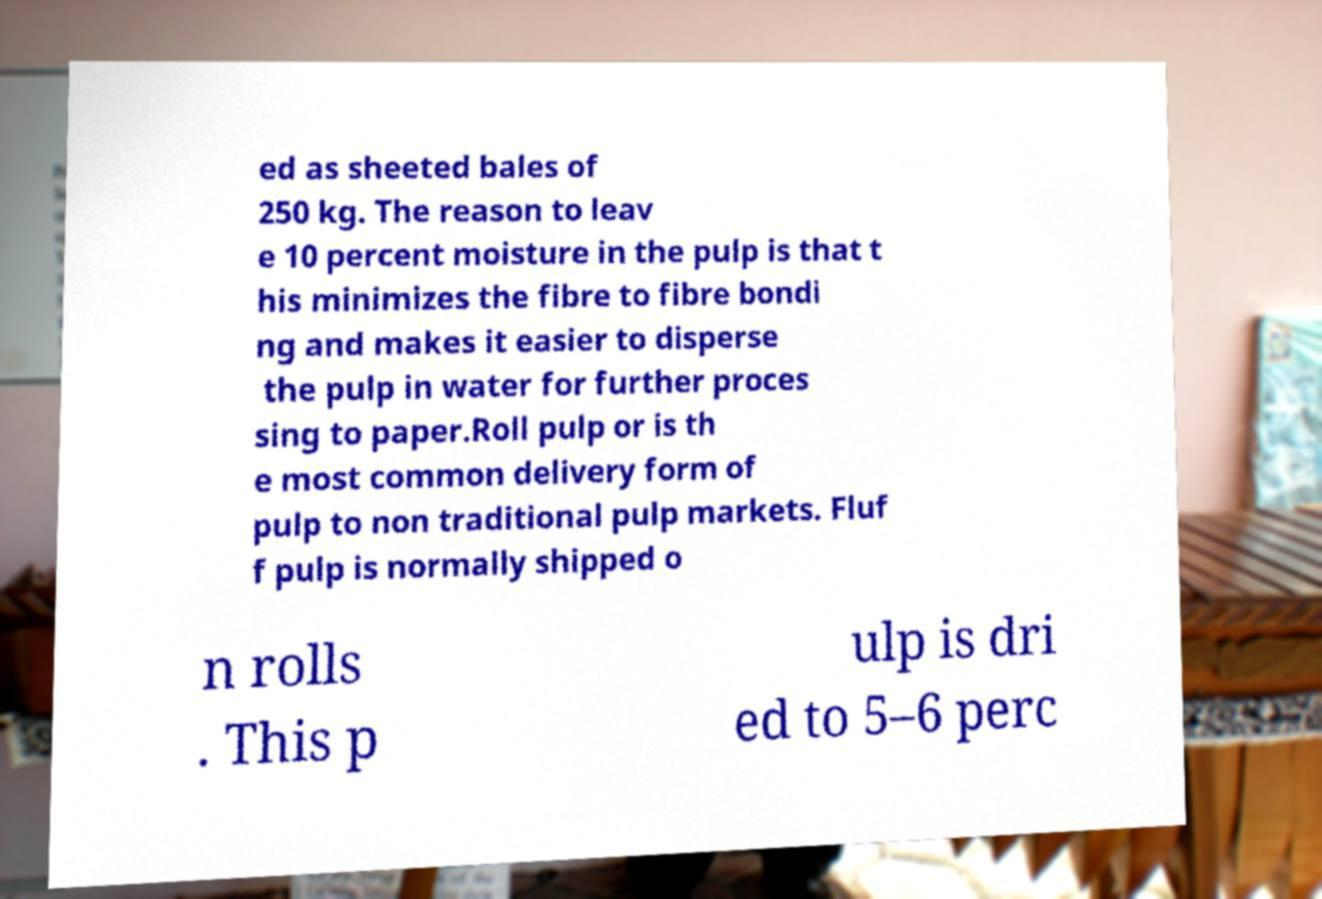Could you extract and type out the text from this image? ed as sheeted bales of 250 kg. The reason to leav e 10 percent moisture in the pulp is that t his minimizes the fibre to fibre bondi ng and makes it easier to disperse the pulp in water for further proces sing to paper.Roll pulp or is th e most common delivery form of pulp to non traditional pulp markets. Fluf f pulp is normally shipped o n rolls . This p ulp is dri ed to 5–6 perc 